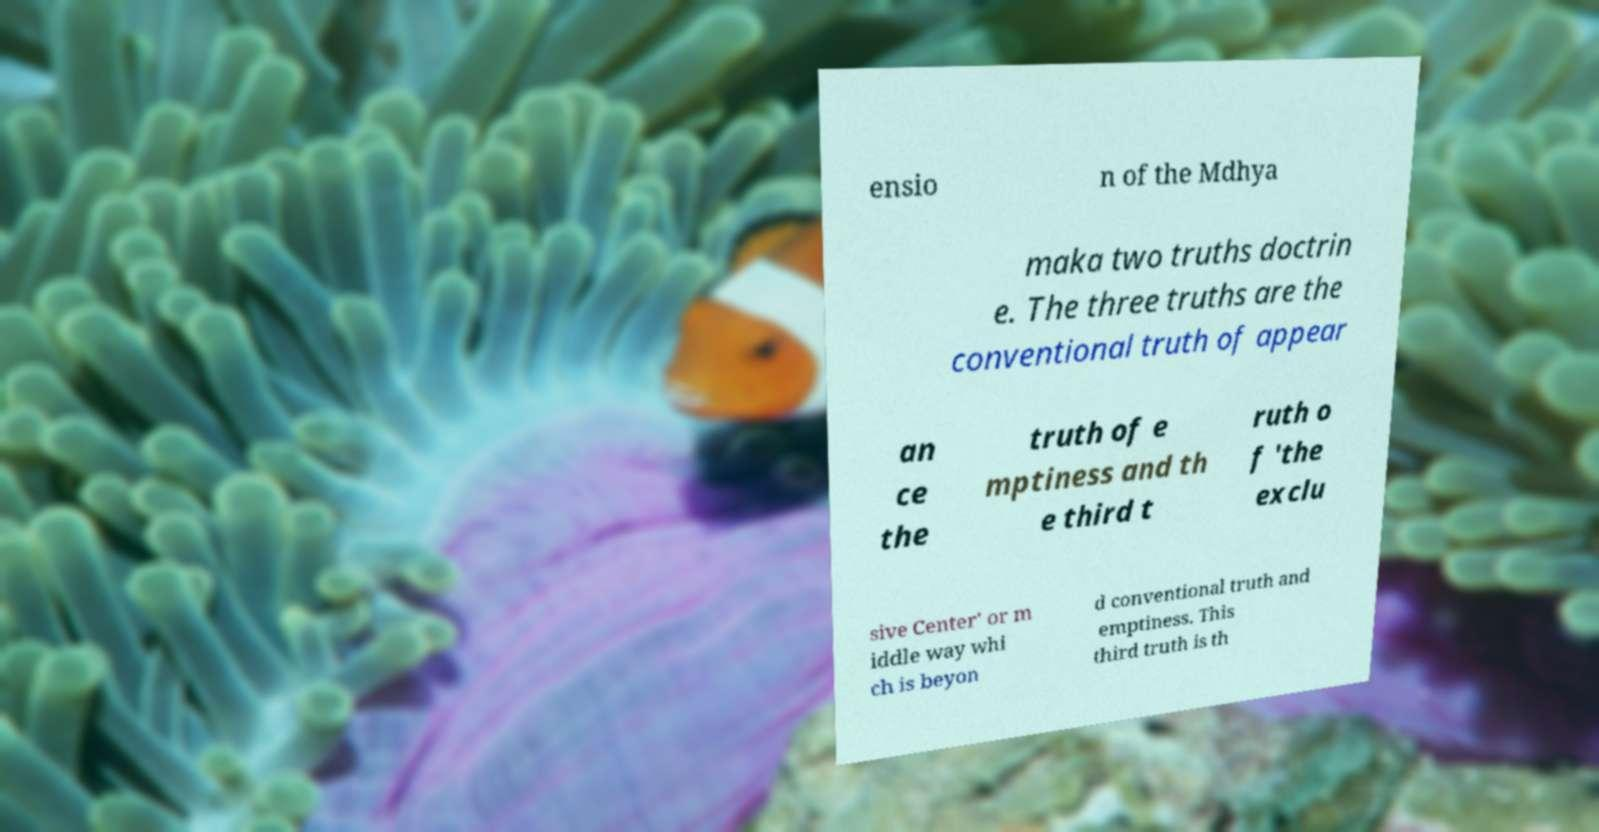There's text embedded in this image that I need extracted. Can you transcribe it verbatim? ensio n of the Mdhya maka two truths doctrin e. The three truths are the conventional truth of appear an ce the truth of e mptiness and th e third t ruth o f 'the exclu sive Center' or m iddle way whi ch is beyon d conventional truth and emptiness. This third truth is th 